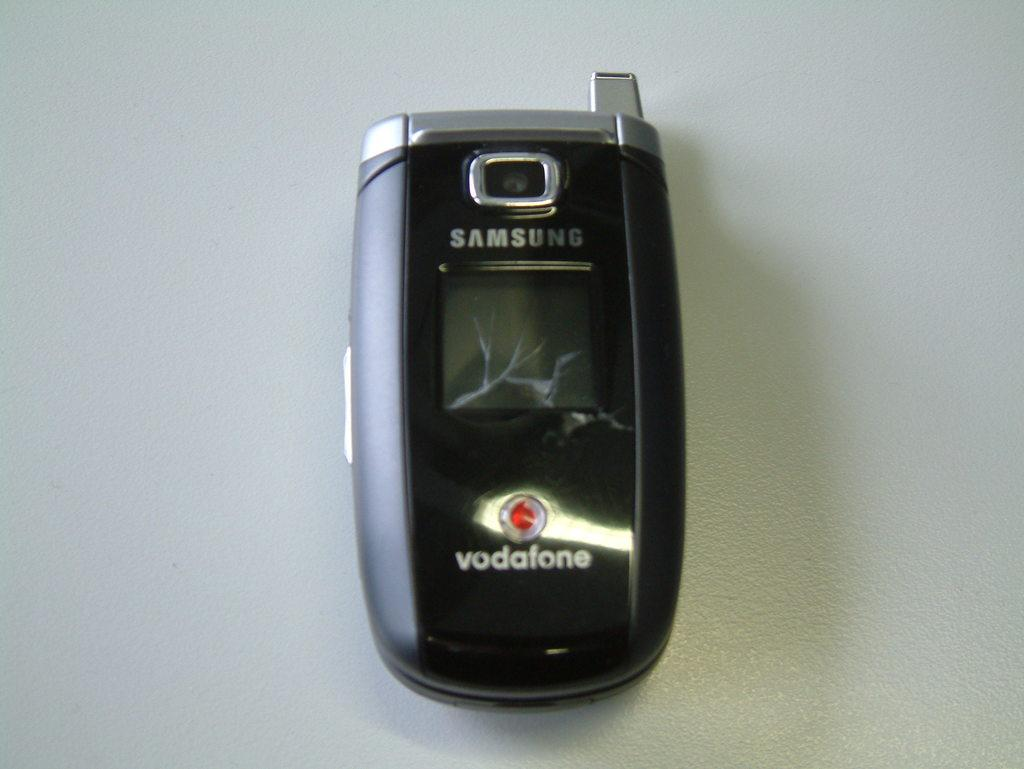<image>
Offer a succinct explanation of the picture presented. An old Samsung phone with service by  Vodafone. 